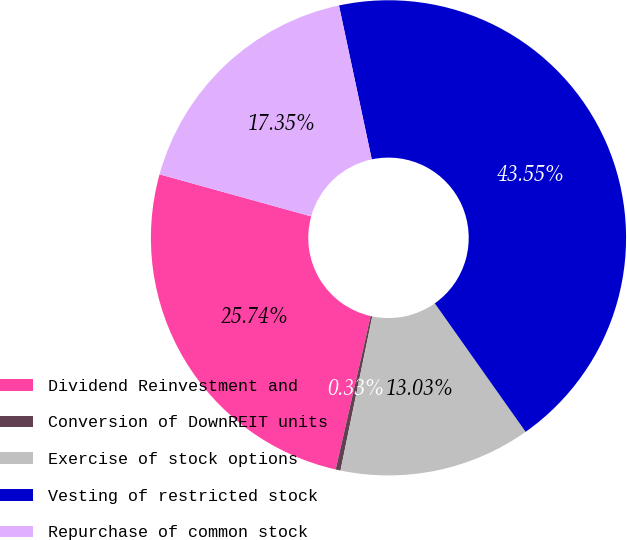Convert chart. <chart><loc_0><loc_0><loc_500><loc_500><pie_chart><fcel>Dividend Reinvestment and<fcel>Conversion of DownREIT units<fcel>Exercise of stock options<fcel>Vesting of restricted stock<fcel>Repurchase of common stock<nl><fcel>25.74%<fcel>0.33%<fcel>13.03%<fcel>43.55%<fcel>17.35%<nl></chart> 